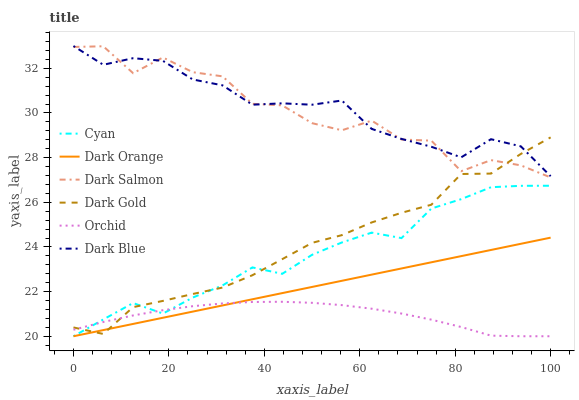Does Orchid have the minimum area under the curve?
Answer yes or no. Yes. Does Dark Blue have the maximum area under the curve?
Answer yes or no. Yes. Does Dark Gold have the minimum area under the curve?
Answer yes or no. No. Does Dark Gold have the maximum area under the curve?
Answer yes or no. No. Is Dark Orange the smoothest?
Answer yes or no. Yes. Is Dark Salmon the roughest?
Answer yes or no. Yes. Is Dark Gold the smoothest?
Answer yes or no. No. Is Dark Gold the roughest?
Answer yes or no. No. Does Dark Orange have the lowest value?
Answer yes or no. Yes. Does Dark Gold have the lowest value?
Answer yes or no. No. Does Dark Blue have the highest value?
Answer yes or no. Yes. Does Dark Gold have the highest value?
Answer yes or no. No. Is Dark Orange less than Dark Blue?
Answer yes or no. Yes. Is Dark Salmon greater than Dark Orange?
Answer yes or no. Yes. Does Orchid intersect Dark Gold?
Answer yes or no. Yes. Is Orchid less than Dark Gold?
Answer yes or no. No. Is Orchid greater than Dark Gold?
Answer yes or no. No. Does Dark Orange intersect Dark Blue?
Answer yes or no. No. 